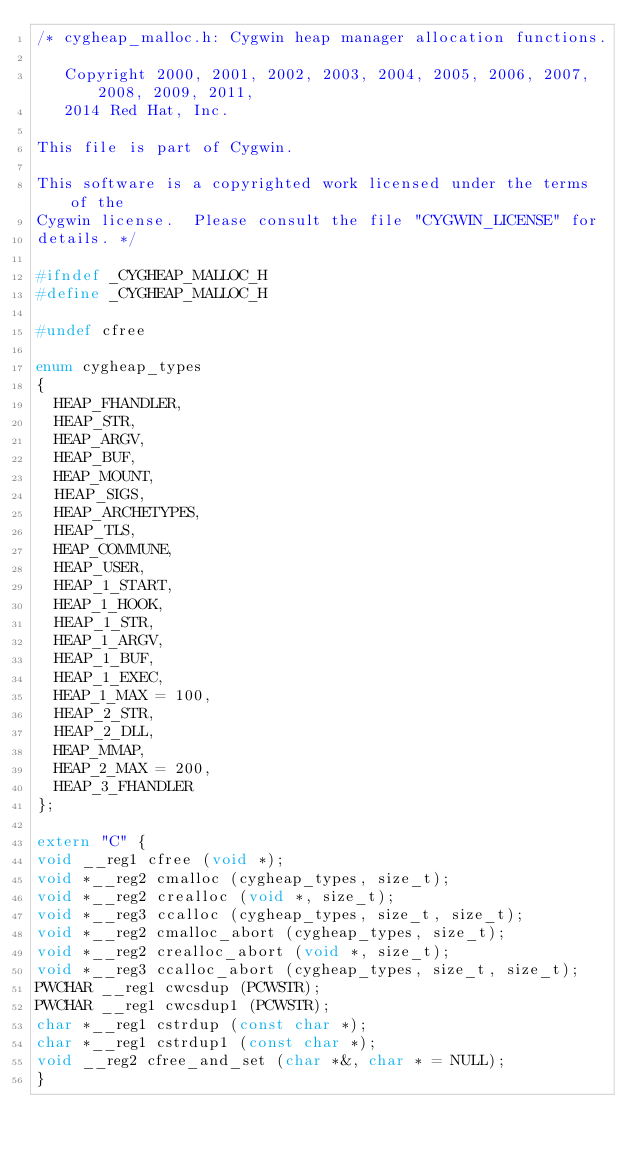Convert code to text. <code><loc_0><loc_0><loc_500><loc_500><_C_>/* cygheap_malloc.h: Cygwin heap manager allocation functions.

   Copyright 2000, 2001, 2002, 2003, 2004, 2005, 2006, 2007, 2008, 2009, 2011,
   2014 Red Hat, Inc.

This file is part of Cygwin.

This software is a copyrighted work licensed under the terms of the
Cygwin license.  Please consult the file "CYGWIN_LICENSE" for
details. */

#ifndef _CYGHEAP_MALLOC_H
#define _CYGHEAP_MALLOC_H

#undef cfree

enum cygheap_types
{
  HEAP_FHANDLER,
  HEAP_STR,
  HEAP_ARGV,
  HEAP_BUF,
  HEAP_MOUNT,
  HEAP_SIGS,
  HEAP_ARCHETYPES,
  HEAP_TLS,
  HEAP_COMMUNE,
  HEAP_USER,
  HEAP_1_START,
  HEAP_1_HOOK,
  HEAP_1_STR,
  HEAP_1_ARGV,
  HEAP_1_BUF,
  HEAP_1_EXEC,
  HEAP_1_MAX = 100,
  HEAP_2_STR,
  HEAP_2_DLL,
  HEAP_MMAP,
  HEAP_2_MAX = 200,
  HEAP_3_FHANDLER
};

extern "C" {
void __reg1 cfree (void *);
void *__reg2 cmalloc (cygheap_types, size_t);
void *__reg2 crealloc (void *, size_t);
void *__reg3 ccalloc (cygheap_types, size_t, size_t);
void *__reg2 cmalloc_abort (cygheap_types, size_t);
void *__reg2 crealloc_abort (void *, size_t);
void *__reg3 ccalloc_abort (cygheap_types, size_t, size_t);
PWCHAR __reg1 cwcsdup (PCWSTR);
PWCHAR __reg1 cwcsdup1 (PCWSTR);
char *__reg1 cstrdup (const char *);
char *__reg1 cstrdup1 (const char *);
void __reg2 cfree_and_set (char *&, char * = NULL);
}
</code> 